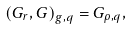<formula> <loc_0><loc_0><loc_500><loc_500>\left ( G _ { r } , G \right ) _ { g , q } = G _ { \rho , q } ,</formula> 